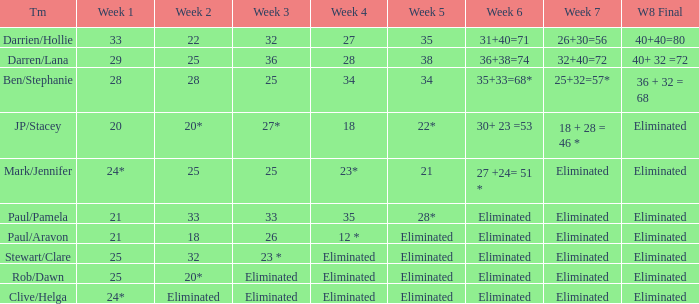Name the week 3 with week 6 of 31+40=71 32.0. 